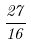<formula> <loc_0><loc_0><loc_500><loc_500>\frac { 2 7 } { 1 6 }</formula> 